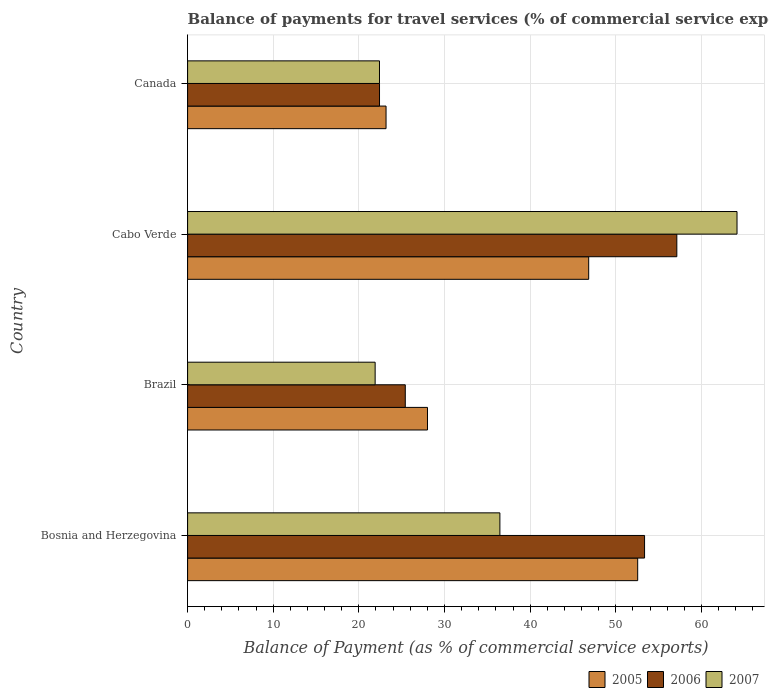How many different coloured bars are there?
Your answer should be compact. 3. How many groups of bars are there?
Provide a short and direct response. 4. Are the number of bars per tick equal to the number of legend labels?
Provide a short and direct response. Yes. How many bars are there on the 3rd tick from the top?
Your response must be concise. 3. What is the label of the 3rd group of bars from the top?
Ensure brevity in your answer.  Brazil. What is the balance of payments for travel services in 2006 in Canada?
Your answer should be compact. 22.41. Across all countries, what is the maximum balance of payments for travel services in 2006?
Keep it short and to the point. 57.13. Across all countries, what is the minimum balance of payments for travel services in 2005?
Provide a short and direct response. 23.17. In which country was the balance of payments for travel services in 2006 maximum?
Offer a terse response. Cabo Verde. What is the total balance of payments for travel services in 2006 in the graph?
Offer a terse response. 158.33. What is the difference between the balance of payments for travel services in 2006 in Brazil and that in Canada?
Offer a very short reply. 3.01. What is the difference between the balance of payments for travel services in 2005 in Canada and the balance of payments for travel services in 2006 in Cabo Verde?
Provide a succinct answer. -33.96. What is the average balance of payments for travel services in 2007 per country?
Give a very brief answer. 36.23. What is the difference between the balance of payments for travel services in 2005 and balance of payments for travel services in 2007 in Brazil?
Offer a very short reply. 6.11. What is the ratio of the balance of payments for travel services in 2005 in Cabo Verde to that in Canada?
Provide a succinct answer. 2.02. Is the difference between the balance of payments for travel services in 2005 in Cabo Verde and Canada greater than the difference between the balance of payments for travel services in 2007 in Cabo Verde and Canada?
Give a very brief answer. No. What is the difference between the highest and the second highest balance of payments for travel services in 2007?
Make the answer very short. 27.69. What is the difference between the highest and the lowest balance of payments for travel services in 2007?
Your answer should be compact. 42.26. In how many countries, is the balance of payments for travel services in 2005 greater than the average balance of payments for travel services in 2005 taken over all countries?
Offer a very short reply. 2. Is it the case that in every country, the sum of the balance of payments for travel services in 2006 and balance of payments for travel services in 2005 is greater than the balance of payments for travel services in 2007?
Give a very brief answer. Yes. Are the values on the major ticks of X-axis written in scientific E-notation?
Offer a terse response. No. Does the graph contain any zero values?
Offer a terse response. No. Does the graph contain grids?
Your answer should be very brief. Yes. Where does the legend appear in the graph?
Ensure brevity in your answer.  Bottom right. How many legend labels are there?
Keep it short and to the point. 3. How are the legend labels stacked?
Offer a terse response. Horizontal. What is the title of the graph?
Offer a terse response. Balance of payments for travel services (% of commercial service exports). What is the label or title of the X-axis?
Offer a very short reply. Balance of Payment (as % of commercial service exports). What is the Balance of Payment (as % of commercial service exports) in 2005 in Bosnia and Herzegovina?
Provide a short and direct response. 52.56. What is the Balance of Payment (as % of commercial service exports) of 2006 in Bosnia and Herzegovina?
Your answer should be compact. 53.36. What is the Balance of Payment (as % of commercial service exports) of 2007 in Bosnia and Herzegovina?
Provide a succinct answer. 36.47. What is the Balance of Payment (as % of commercial service exports) of 2005 in Brazil?
Provide a succinct answer. 28.01. What is the Balance of Payment (as % of commercial service exports) in 2006 in Brazil?
Offer a terse response. 25.42. What is the Balance of Payment (as % of commercial service exports) in 2007 in Brazil?
Offer a terse response. 21.9. What is the Balance of Payment (as % of commercial service exports) of 2005 in Cabo Verde?
Your response must be concise. 46.84. What is the Balance of Payment (as % of commercial service exports) of 2006 in Cabo Verde?
Your answer should be compact. 57.13. What is the Balance of Payment (as % of commercial service exports) of 2007 in Cabo Verde?
Offer a terse response. 64.16. What is the Balance of Payment (as % of commercial service exports) in 2005 in Canada?
Make the answer very short. 23.17. What is the Balance of Payment (as % of commercial service exports) of 2006 in Canada?
Offer a very short reply. 22.41. What is the Balance of Payment (as % of commercial service exports) of 2007 in Canada?
Your answer should be compact. 22.41. Across all countries, what is the maximum Balance of Payment (as % of commercial service exports) in 2005?
Your answer should be compact. 52.56. Across all countries, what is the maximum Balance of Payment (as % of commercial service exports) of 2006?
Ensure brevity in your answer.  57.13. Across all countries, what is the maximum Balance of Payment (as % of commercial service exports) of 2007?
Give a very brief answer. 64.16. Across all countries, what is the minimum Balance of Payment (as % of commercial service exports) in 2005?
Keep it short and to the point. 23.17. Across all countries, what is the minimum Balance of Payment (as % of commercial service exports) in 2006?
Provide a succinct answer. 22.41. Across all countries, what is the minimum Balance of Payment (as % of commercial service exports) in 2007?
Offer a terse response. 21.9. What is the total Balance of Payment (as % of commercial service exports) of 2005 in the graph?
Offer a terse response. 150.59. What is the total Balance of Payment (as % of commercial service exports) in 2006 in the graph?
Offer a very short reply. 158.33. What is the total Balance of Payment (as % of commercial service exports) of 2007 in the graph?
Offer a very short reply. 144.94. What is the difference between the Balance of Payment (as % of commercial service exports) in 2005 in Bosnia and Herzegovina and that in Brazil?
Offer a very short reply. 24.55. What is the difference between the Balance of Payment (as % of commercial service exports) in 2006 in Bosnia and Herzegovina and that in Brazil?
Offer a terse response. 27.94. What is the difference between the Balance of Payment (as % of commercial service exports) of 2007 in Bosnia and Herzegovina and that in Brazil?
Provide a succinct answer. 14.57. What is the difference between the Balance of Payment (as % of commercial service exports) in 2005 in Bosnia and Herzegovina and that in Cabo Verde?
Ensure brevity in your answer.  5.72. What is the difference between the Balance of Payment (as % of commercial service exports) of 2006 in Bosnia and Herzegovina and that in Cabo Verde?
Give a very brief answer. -3.77. What is the difference between the Balance of Payment (as % of commercial service exports) of 2007 in Bosnia and Herzegovina and that in Cabo Verde?
Make the answer very short. -27.69. What is the difference between the Balance of Payment (as % of commercial service exports) of 2005 in Bosnia and Herzegovina and that in Canada?
Offer a very short reply. 29.39. What is the difference between the Balance of Payment (as % of commercial service exports) of 2006 in Bosnia and Herzegovina and that in Canada?
Make the answer very short. 30.95. What is the difference between the Balance of Payment (as % of commercial service exports) of 2007 in Bosnia and Herzegovina and that in Canada?
Offer a very short reply. 14.06. What is the difference between the Balance of Payment (as % of commercial service exports) in 2005 in Brazil and that in Cabo Verde?
Your response must be concise. -18.82. What is the difference between the Balance of Payment (as % of commercial service exports) in 2006 in Brazil and that in Cabo Verde?
Keep it short and to the point. -31.71. What is the difference between the Balance of Payment (as % of commercial service exports) of 2007 in Brazil and that in Cabo Verde?
Provide a short and direct response. -42.26. What is the difference between the Balance of Payment (as % of commercial service exports) in 2005 in Brazil and that in Canada?
Offer a terse response. 4.84. What is the difference between the Balance of Payment (as % of commercial service exports) in 2006 in Brazil and that in Canada?
Your response must be concise. 3.01. What is the difference between the Balance of Payment (as % of commercial service exports) of 2007 in Brazil and that in Canada?
Your answer should be very brief. -0.51. What is the difference between the Balance of Payment (as % of commercial service exports) in 2005 in Cabo Verde and that in Canada?
Your answer should be very brief. 23.66. What is the difference between the Balance of Payment (as % of commercial service exports) in 2006 in Cabo Verde and that in Canada?
Ensure brevity in your answer.  34.72. What is the difference between the Balance of Payment (as % of commercial service exports) in 2007 in Cabo Verde and that in Canada?
Give a very brief answer. 41.75. What is the difference between the Balance of Payment (as % of commercial service exports) of 2005 in Bosnia and Herzegovina and the Balance of Payment (as % of commercial service exports) of 2006 in Brazil?
Your response must be concise. 27.14. What is the difference between the Balance of Payment (as % of commercial service exports) in 2005 in Bosnia and Herzegovina and the Balance of Payment (as % of commercial service exports) in 2007 in Brazil?
Provide a succinct answer. 30.66. What is the difference between the Balance of Payment (as % of commercial service exports) of 2006 in Bosnia and Herzegovina and the Balance of Payment (as % of commercial service exports) of 2007 in Brazil?
Offer a terse response. 31.46. What is the difference between the Balance of Payment (as % of commercial service exports) of 2005 in Bosnia and Herzegovina and the Balance of Payment (as % of commercial service exports) of 2006 in Cabo Verde?
Ensure brevity in your answer.  -4.57. What is the difference between the Balance of Payment (as % of commercial service exports) of 2005 in Bosnia and Herzegovina and the Balance of Payment (as % of commercial service exports) of 2007 in Cabo Verde?
Provide a short and direct response. -11.6. What is the difference between the Balance of Payment (as % of commercial service exports) in 2006 in Bosnia and Herzegovina and the Balance of Payment (as % of commercial service exports) in 2007 in Cabo Verde?
Keep it short and to the point. -10.8. What is the difference between the Balance of Payment (as % of commercial service exports) in 2005 in Bosnia and Herzegovina and the Balance of Payment (as % of commercial service exports) in 2006 in Canada?
Your answer should be very brief. 30.15. What is the difference between the Balance of Payment (as % of commercial service exports) in 2005 in Bosnia and Herzegovina and the Balance of Payment (as % of commercial service exports) in 2007 in Canada?
Provide a succinct answer. 30.15. What is the difference between the Balance of Payment (as % of commercial service exports) in 2006 in Bosnia and Herzegovina and the Balance of Payment (as % of commercial service exports) in 2007 in Canada?
Provide a short and direct response. 30.96. What is the difference between the Balance of Payment (as % of commercial service exports) in 2005 in Brazil and the Balance of Payment (as % of commercial service exports) in 2006 in Cabo Verde?
Make the answer very short. -29.12. What is the difference between the Balance of Payment (as % of commercial service exports) in 2005 in Brazil and the Balance of Payment (as % of commercial service exports) in 2007 in Cabo Verde?
Your answer should be compact. -36.15. What is the difference between the Balance of Payment (as % of commercial service exports) in 2006 in Brazil and the Balance of Payment (as % of commercial service exports) in 2007 in Cabo Verde?
Keep it short and to the point. -38.74. What is the difference between the Balance of Payment (as % of commercial service exports) of 2005 in Brazil and the Balance of Payment (as % of commercial service exports) of 2006 in Canada?
Your response must be concise. 5.6. What is the difference between the Balance of Payment (as % of commercial service exports) of 2005 in Brazil and the Balance of Payment (as % of commercial service exports) of 2007 in Canada?
Provide a succinct answer. 5.61. What is the difference between the Balance of Payment (as % of commercial service exports) of 2006 in Brazil and the Balance of Payment (as % of commercial service exports) of 2007 in Canada?
Provide a succinct answer. 3.01. What is the difference between the Balance of Payment (as % of commercial service exports) in 2005 in Cabo Verde and the Balance of Payment (as % of commercial service exports) in 2006 in Canada?
Make the answer very short. 24.43. What is the difference between the Balance of Payment (as % of commercial service exports) of 2005 in Cabo Verde and the Balance of Payment (as % of commercial service exports) of 2007 in Canada?
Provide a succinct answer. 24.43. What is the difference between the Balance of Payment (as % of commercial service exports) in 2006 in Cabo Verde and the Balance of Payment (as % of commercial service exports) in 2007 in Canada?
Keep it short and to the point. 34.72. What is the average Balance of Payment (as % of commercial service exports) in 2005 per country?
Offer a terse response. 37.65. What is the average Balance of Payment (as % of commercial service exports) in 2006 per country?
Provide a short and direct response. 39.58. What is the average Balance of Payment (as % of commercial service exports) in 2007 per country?
Offer a terse response. 36.23. What is the difference between the Balance of Payment (as % of commercial service exports) in 2005 and Balance of Payment (as % of commercial service exports) in 2006 in Bosnia and Herzegovina?
Keep it short and to the point. -0.8. What is the difference between the Balance of Payment (as % of commercial service exports) of 2005 and Balance of Payment (as % of commercial service exports) of 2007 in Bosnia and Herzegovina?
Make the answer very short. 16.09. What is the difference between the Balance of Payment (as % of commercial service exports) of 2006 and Balance of Payment (as % of commercial service exports) of 2007 in Bosnia and Herzegovina?
Keep it short and to the point. 16.9. What is the difference between the Balance of Payment (as % of commercial service exports) in 2005 and Balance of Payment (as % of commercial service exports) in 2006 in Brazil?
Offer a terse response. 2.59. What is the difference between the Balance of Payment (as % of commercial service exports) in 2005 and Balance of Payment (as % of commercial service exports) in 2007 in Brazil?
Provide a short and direct response. 6.11. What is the difference between the Balance of Payment (as % of commercial service exports) in 2006 and Balance of Payment (as % of commercial service exports) in 2007 in Brazil?
Keep it short and to the point. 3.52. What is the difference between the Balance of Payment (as % of commercial service exports) of 2005 and Balance of Payment (as % of commercial service exports) of 2006 in Cabo Verde?
Offer a very short reply. -10.29. What is the difference between the Balance of Payment (as % of commercial service exports) in 2005 and Balance of Payment (as % of commercial service exports) in 2007 in Cabo Verde?
Keep it short and to the point. -17.32. What is the difference between the Balance of Payment (as % of commercial service exports) in 2006 and Balance of Payment (as % of commercial service exports) in 2007 in Cabo Verde?
Your answer should be very brief. -7.03. What is the difference between the Balance of Payment (as % of commercial service exports) in 2005 and Balance of Payment (as % of commercial service exports) in 2006 in Canada?
Your response must be concise. 0.76. What is the difference between the Balance of Payment (as % of commercial service exports) in 2005 and Balance of Payment (as % of commercial service exports) in 2007 in Canada?
Your response must be concise. 0.77. What is the difference between the Balance of Payment (as % of commercial service exports) of 2006 and Balance of Payment (as % of commercial service exports) of 2007 in Canada?
Your answer should be compact. 0. What is the ratio of the Balance of Payment (as % of commercial service exports) in 2005 in Bosnia and Herzegovina to that in Brazil?
Provide a succinct answer. 1.88. What is the ratio of the Balance of Payment (as % of commercial service exports) in 2006 in Bosnia and Herzegovina to that in Brazil?
Your answer should be compact. 2.1. What is the ratio of the Balance of Payment (as % of commercial service exports) in 2007 in Bosnia and Herzegovina to that in Brazil?
Offer a terse response. 1.67. What is the ratio of the Balance of Payment (as % of commercial service exports) of 2005 in Bosnia and Herzegovina to that in Cabo Verde?
Ensure brevity in your answer.  1.12. What is the ratio of the Balance of Payment (as % of commercial service exports) of 2006 in Bosnia and Herzegovina to that in Cabo Verde?
Ensure brevity in your answer.  0.93. What is the ratio of the Balance of Payment (as % of commercial service exports) of 2007 in Bosnia and Herzegovina to that in Cabo Verde?
Ensure brevity in your answer.  0.57. What is the ratio of the Balance of Payment (as % of commercial service exports) of 2005 in Bosnia and Herzegovina to that in Canada?
Your answer should be compact. 2.27. What is the ratio of the Balance of Payment (as % of commercial service exports) in 2006 in Bosnia and Herzegovina to that in Canada?
Make the answer very short. 2.38. What is the ratio of the Balance of Payment (as % of commercial service exports) in 2007 in Bosnia and Herzegovina to that in Canada?
Provide a short and direct response. 1.63. What is the ratio of the Balance of Payment (as % of commercial service exports) in 2005 in Brazil to that in Cabo Verde?
Offer a very short reply. 0.6. What is the ratio of the Balance of Payment (as % of commercial service exports) of 2006 in Brazil to that in Cabo Verde?
Provide a succinct answer. 0.44. What is the ratio of the Balance of Payment (as % of commercial service exports) of 2007 in Brazil to that in Cabo Verde?
Ensure brevity in your answer.  0.34. What is the ratio of the Balance of Payment (as % of commercial service exports) of 2005 in Brazil to that in Canada?
Provide a short and direct response. 1.21. What is the ratio of the Balance of Payment (as % of commercial service exports) of 2006 in Brazil to that in Canada?
Your answer should be compact. 1.13. What is the ratio of the Balance of Payment (as % of commercial service exports) of 2007 in Brazil to that in Canada?
Keep it short and to the point. 0.98. What is the ratio of the Balance of Payment (as % of commercial service exports) in 2005 in Cabo Verde to that in Canada?
Offer a very short reply. 2.02. What is the ratio of the Balance of Payment (as % of commercial service exports) of 2006 in Cabo Verde to that in Canada?
Offer a terse response. 2.55. What is the ratio of the Balance of Payment (as % of commercial service exports) in 2007 in Cabo Verde to that in Canada?
Provide a succinct answer. 2.86. What is the difference between the highest and the second highest Balance of Payment (as % of commercial service exports) in 2005?
Keep it short and to the point. 5.72. What is the difference between the highest and the second highest Balance of Payment (as % of commercial service exports) of 2006?
Offer a terse response. 3.77. What is the difference between the highest and the second highest Balance of Payment (as % of commercial service exports) in 2007?
Your answer should be compact. 27.69. What is the difference between the highest and the lowest Balance of Payment (as % of commercial service exports) of 2005?
Offer a terse response. 29.39. What is the difference between the highest and the lowest Balance of Payment (as % of commercial service exports) of 2006?
Make the answer very short. 34.72. What is the difference between the highest and the lowest Balance of Payment (as % of commercial service exports) in 2007?
Your answer should be compact. 42.26. 